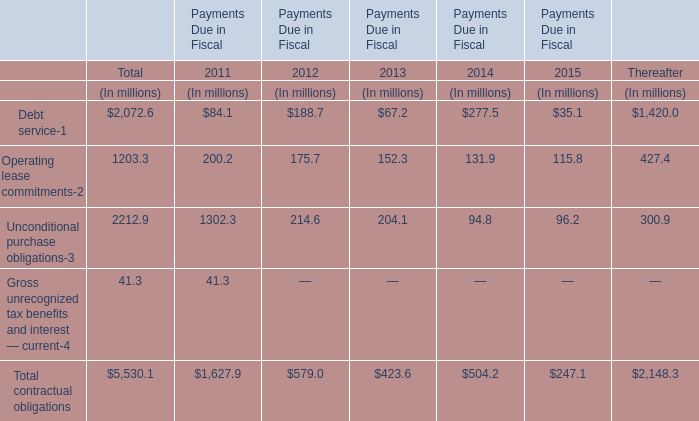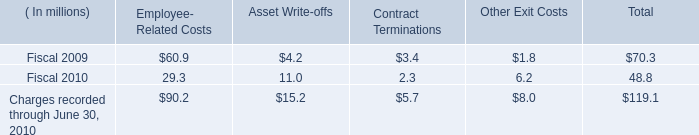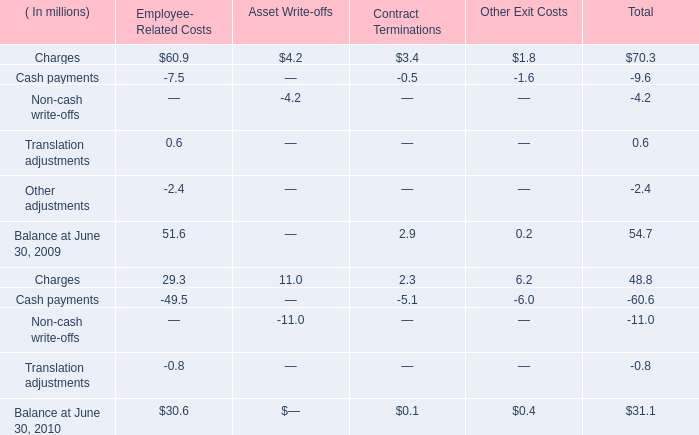What is the growing rate of Cash payments for Total in the year with the most Charges for Total? 
Computations: ((-9.6 + 60.6) / -9.6)
Answer: -5.3125. 